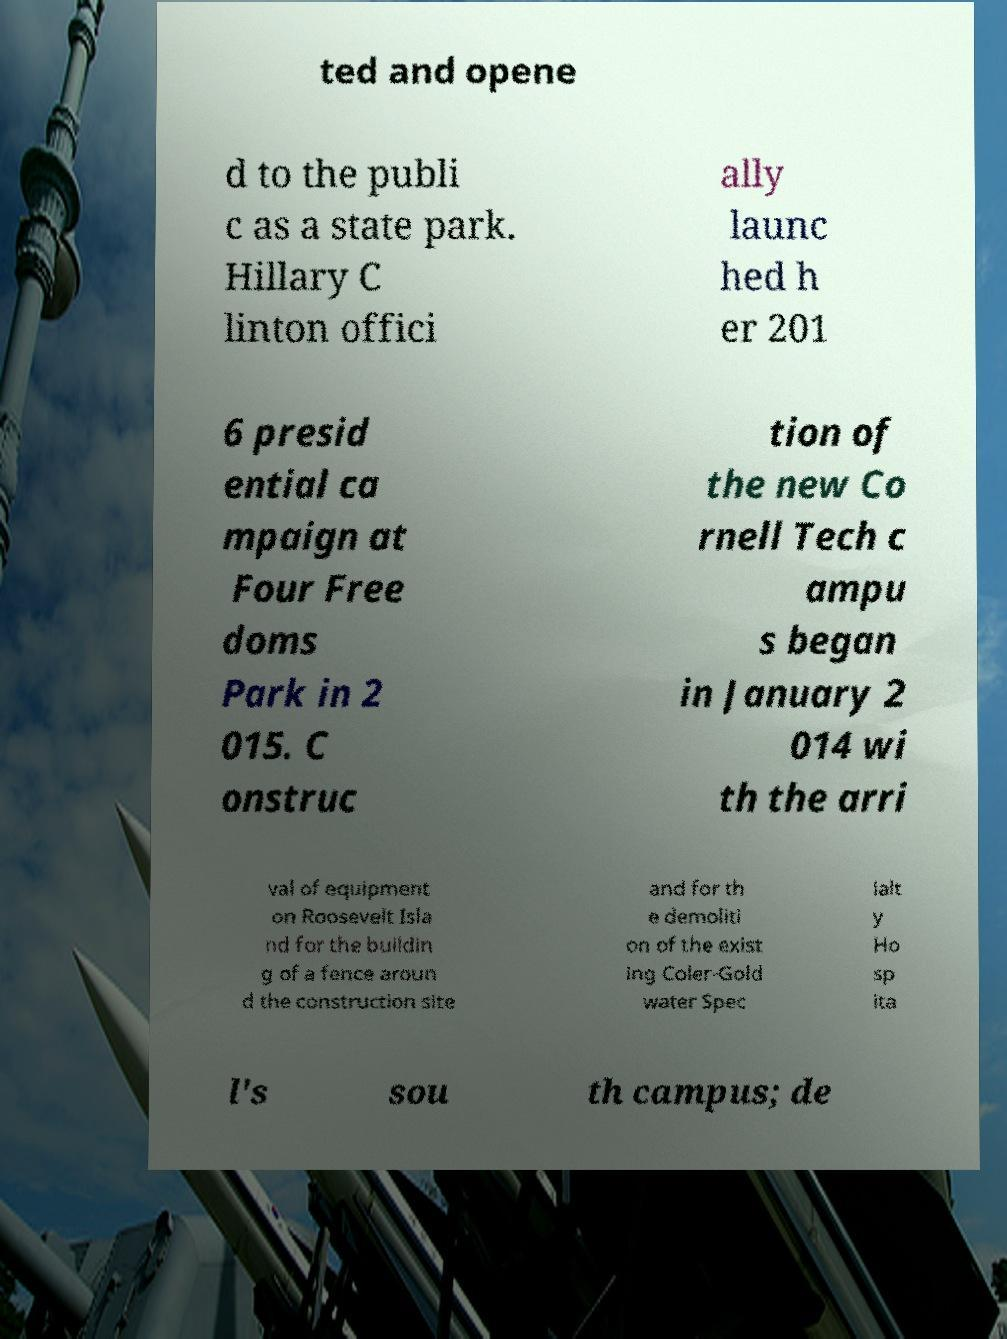What messages or text are displayed in this image? I need them in a readable, typed format. ted and opene d to the publi c as a state park. Hillary C linton offici ally launc hed h er 201 6 presid ential ca mpaign at Four Free doms Park in 2 015. C onstruc tion of the new Co rnell Tech c ampu s began in January 2 014 wi th the arri val of equipment on Roosevelt Isla nd for the buildin g of a fence aroun d the construction site and for th e demoliti on of the exist ing Coler-Gold water Spec ialt y Ho sp ita l's sou th campus; de 